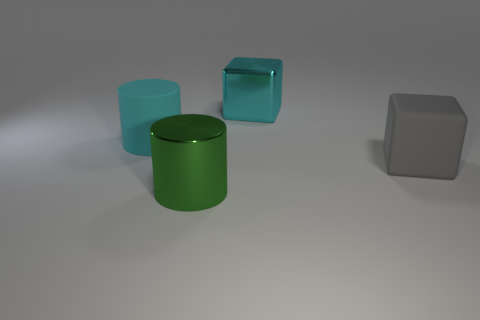What is the size of the block behind the gray matte block?
Your answer should be compact. Large. Are there fewer cyan cylinders than small brown rubber objects?
Ensure brevity in your answer.  No. Does the cyan object that is right of the big green metallic cylinder have the same material as the object on the left side of the shiny cylinder?
Give a very brief answer. No. The large cyan metallic object to the right of the metal thing left of the big shiny object that is behind the large gray rubber cube is what shape?
Your response must be concise. Cube. What number of big cyan cylinders have the same material as the large green thing?
Provide a short and direct response. 0. How many large green metal cylinders are to the left of the matte object that is to the right of the big green metal object?
Make the answer very short. 1. Is the color of the cylinder in front of the large gray object the same as the matte thing to the left of the large green object?
Offer a very short reply. No. What is the shape of the object that is in front of the big cyan rubber object and on the left side of the large matte block?
Offer a terse response. Cylinder. Is there another big rubber object that has the same shape as the large green object?
Keep it short and to the point. Yes. The other matte object that is the same size as the cyan matte thing is what shape?
Give a very brief answer. Cube. 